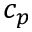<formula> <loc_0><loc_0><loc_500><loc_500>c _ { p }</formula> 